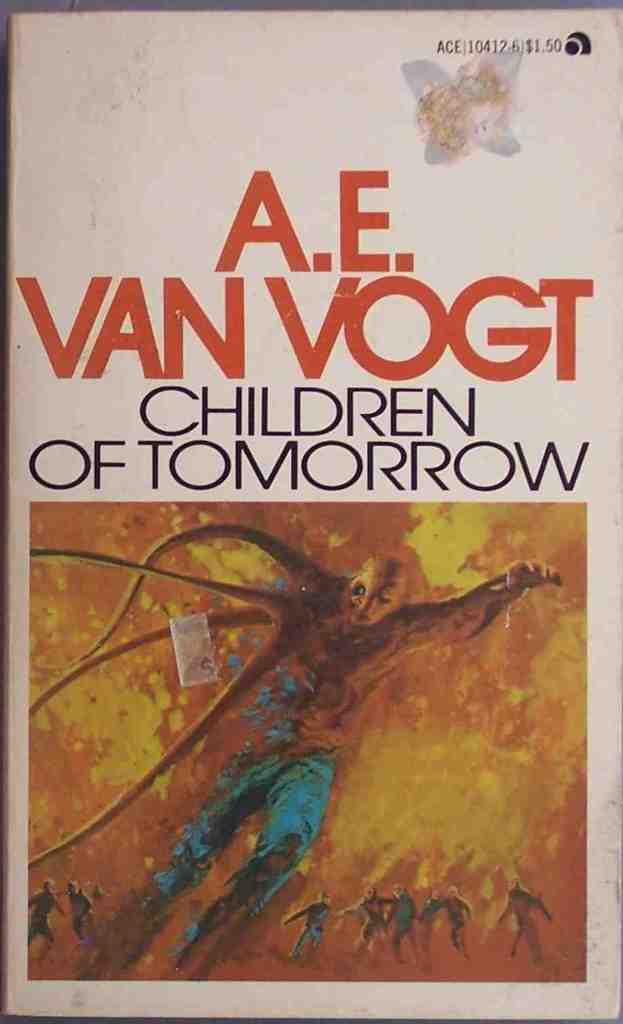<image>
Describe the image concisely. A book from A.E. Van Vogt titled Children of Tomorrow. 